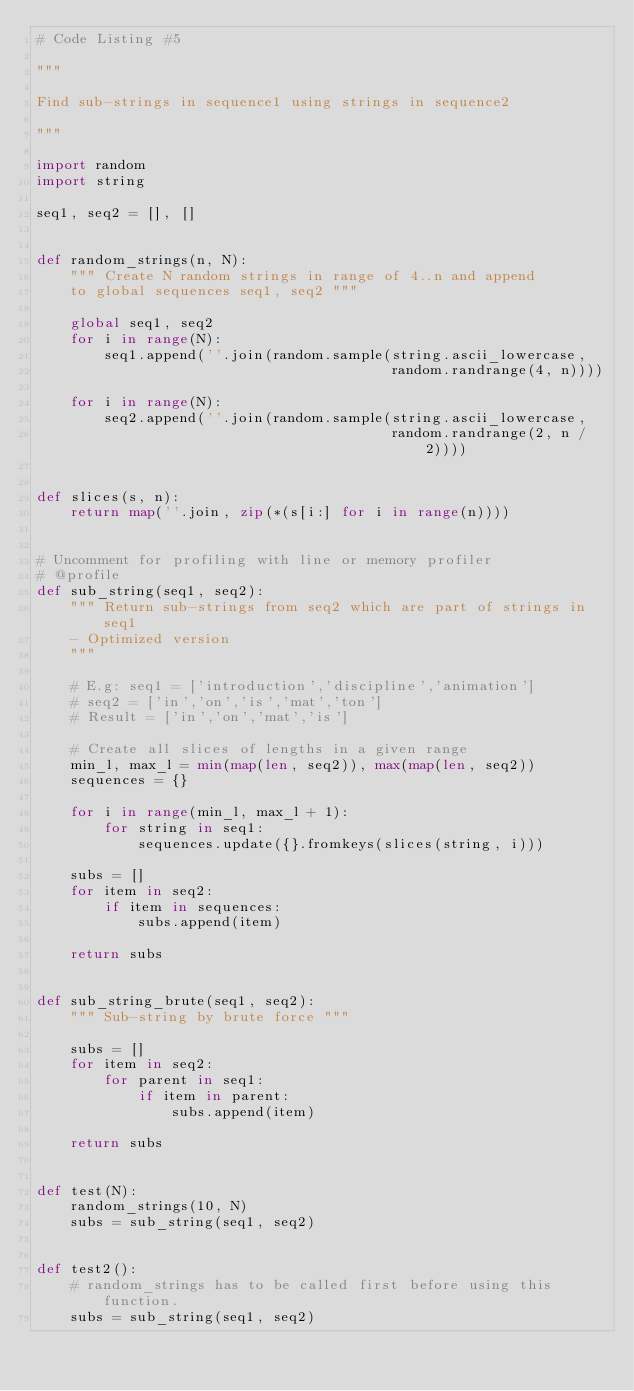Convert code to text. <code><loc_0><loc_0><loc_500><loc_500><_Python_># Code Listing #5

"""

Find sub-strings in sequence1 using strings in sequence2

"""

import random
import string

seq1, seq2 = [], []


def random_strings(n, N):
    """ Create N random strings in range of 4..n and append
    to global sequences seq1, seq2 """

    global seq1, seq2
    for i in range(N):
        seq1.append(''.join(random.sample(string.ascii_lowercase,
                                          random.randrange(4, n))))

    for i in range(N):
        seq2.append(''.join(random.sample(string.ascii_lowercase,
                                          random.randrange(2, n / 2))))


def slices(s, n):
    return map(''.join, zip(*(s[i:] for i in range(n))))


# Uncomment for profiling with line or memory profiler
# @profile
def sub_string(seq1, seq2):
    """ Return sub-strings from seq2 which are part of strings in seq1
    - Optimized version
    """

    # E.g: seq1 = ['introduction','discipline','animation']
    # seq2 = ['in','on','is','mat','ton']
    # Result = ['in','on','mat','is']

    # Create all slices of lengths in a given range
    min_l, max_l = min(map(len, seq2)), max(map(len, seq2))
    sequences = {}

    for i in range(min_l, max_l + 1):
        for string in seq1:
            sequences.update({}.fromkeys(slices(string, i)))

    subs = []
    for item in seq2:
        if item in sequences:
            subs.append(item)

    return subs


def sub_string_brute(seq1, seq2):
    """ Sub-string by brute force """

    subs = []
    for item in seq2:
        for parent in seq1:
            if item in parent:
                subs.append(item)

    return subs


def test(N):
    random_strings(10, N)
    subs = sub_string(seq1, seq2)


def test2():
    # random_strings has to be called first before using this function.
    subs = sub_string(seq1, seq2)
</code> 